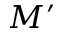Convert formula to latex. <formula><loc_0><loc_0><loc_500><loc_500>M ^ { \prime }</formula> 